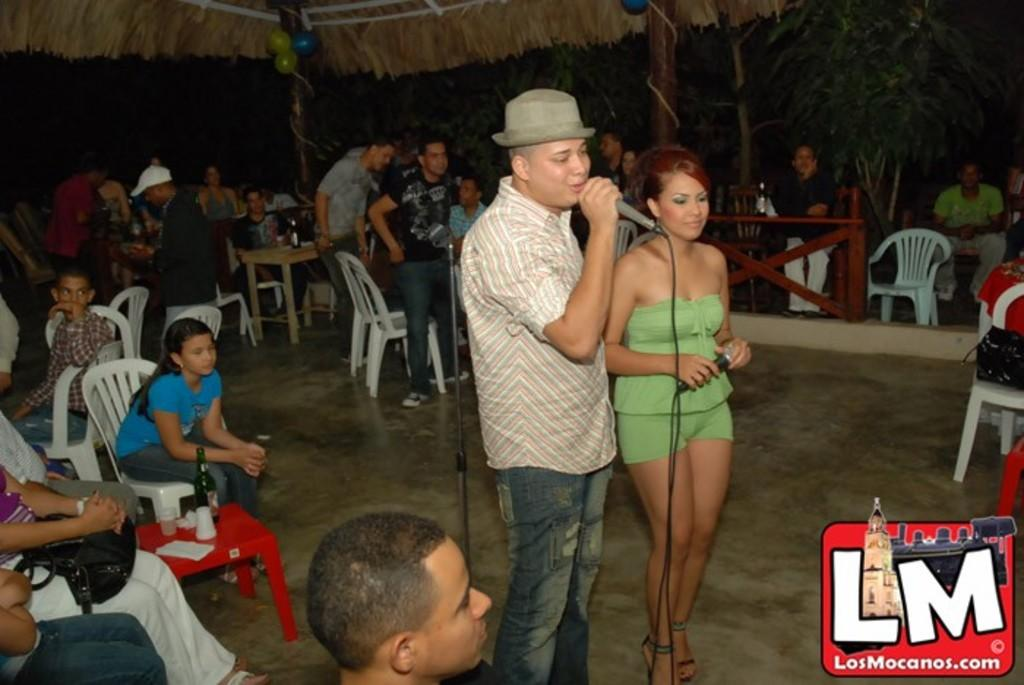What are the people in the image doing? There are people sitting on chairs and standing in the image. What objects are the man and woman holding in their hands? The man and woman are holding microphones in their hands. Where can you find text in the image? There is text in the bottom right corner of the image. How many actors are present in the image? There is no mention of actors in the image, so it cannot be determined how many are present. 